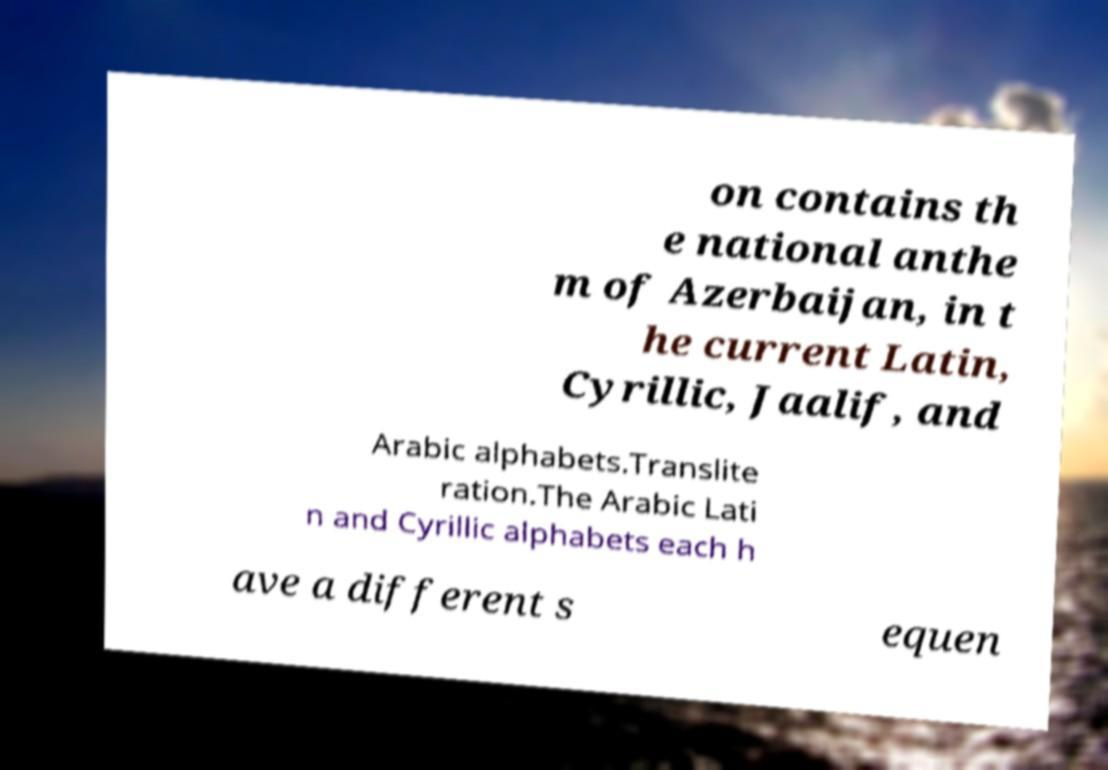What messages or text are displayed in this image? I need them in a readable, typed format. on contains th e national anthe m of Azerbaijan, in t he current Latin, Cyrillic, Jaalif, and Arabic alphabets.Translite ration.The Arabic Lati n and Cyrillic alphabets each h ave a different s equen 